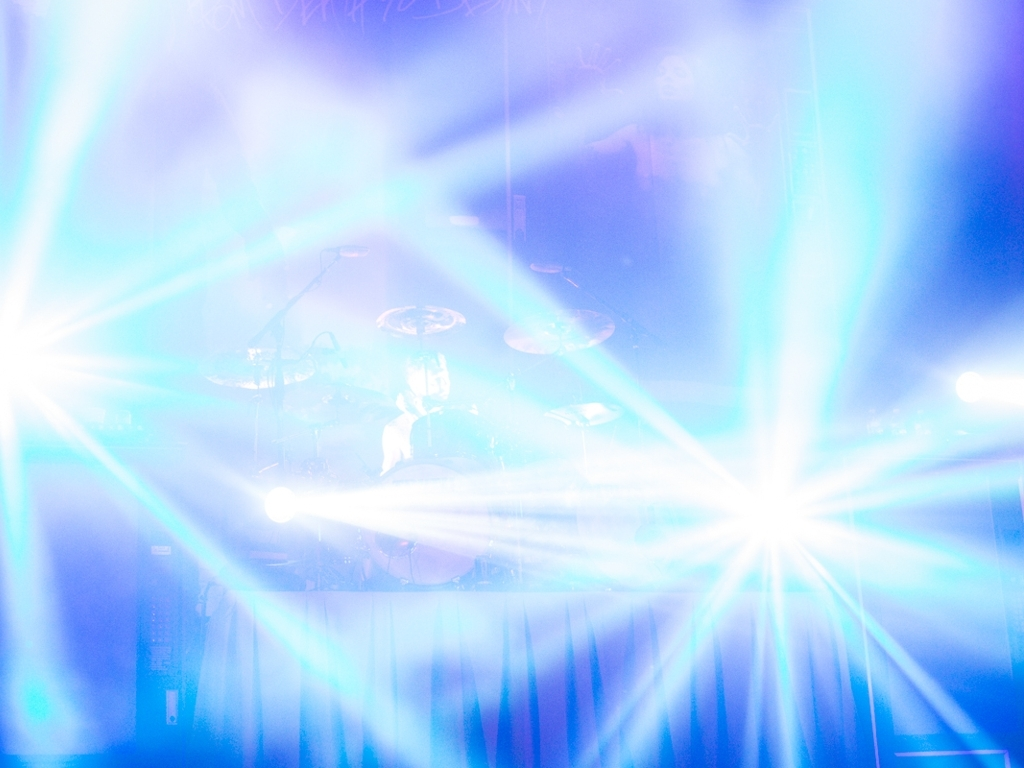What kind of event might this be, considering the bright lights and what appears to be a stage? Given the bright stage lights and a silhouette that can be partially seen, this might be a live concert or a performance event. The lights suggest that it's a dynamic environment, typical for music events where lighting plays a crucial role in creating ambiance. 